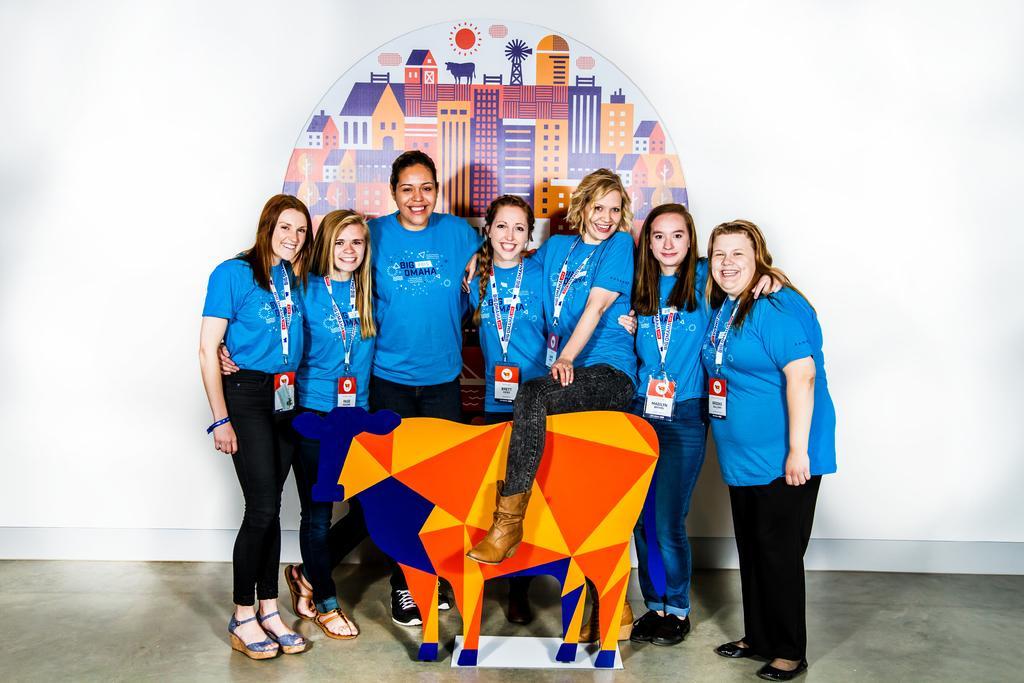Could you give a brief overview of what you see in this image? In the picture I can see a group of women are standing on the floor and smiling. These women are wearing blue color T-shirts, black color pants, footwear and ID cards. In the background I can see a wall which has photo of buildings and some other things. 